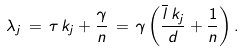Convert formula to latex. <formula><loc_0><loc_0><loc_500><loc_500>\lambda _ { j } \, = \, \tau \, k _ { j } + \frac { \gamma } { n } \, = \, \gamma \left ( \frac { \overline { l } \, k _ { j } } { d } + \frac { 1 } { n } \right ) .</formula> 